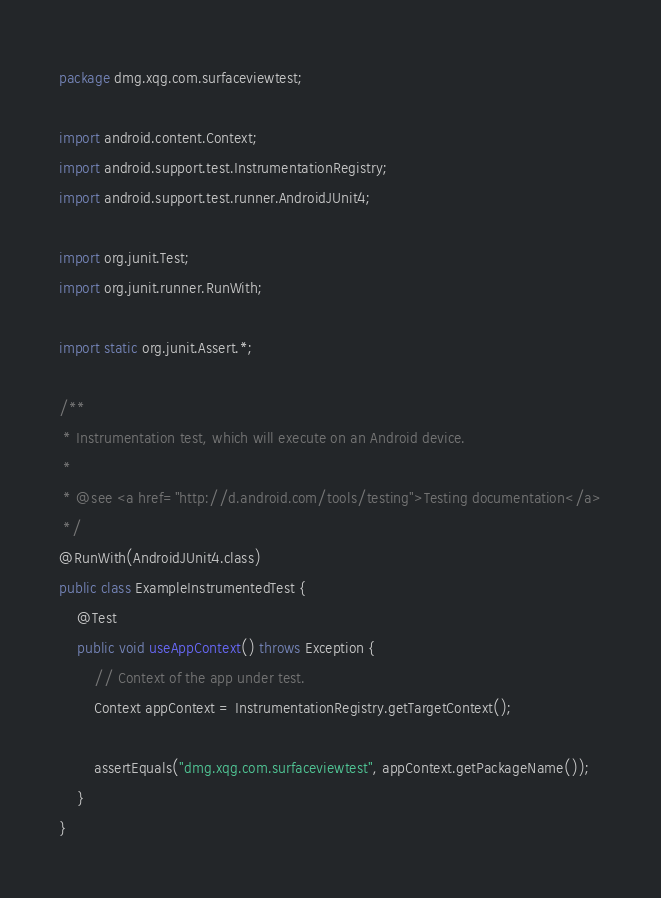Convert code to text. <code><loc_0><loc_0><loc_500><loc_500><_Java_>package dmg.xqg.com.surfaceviewtest;

import android.content.Context;
import android.support.test.InstrumentationRegistry;
import android.support.test.runner.AndroidJUnit4;

import org.junit.Test;
import org.junit.runner.RunWith;

import static org.junit.Assert.*;

/**
 * Instrumentation test, which will execute on an Android device.
 *
 * @see <a href="http://d.android.com/tools/testing">Testing documentation</a>
 */
@RunWith(AndroidJUnit4.class)
public class ExampleInstrumentedTest {
    @Test
    public void useAppContext() throws Exception {
        // Context of the app under test.
        Context appContext = InstrumentationRegistry.getTargetContext();

        assertEquals("dmg.xqg.com.surfaceviewtest", appContext.getPackageName());
    }
}
</code> 